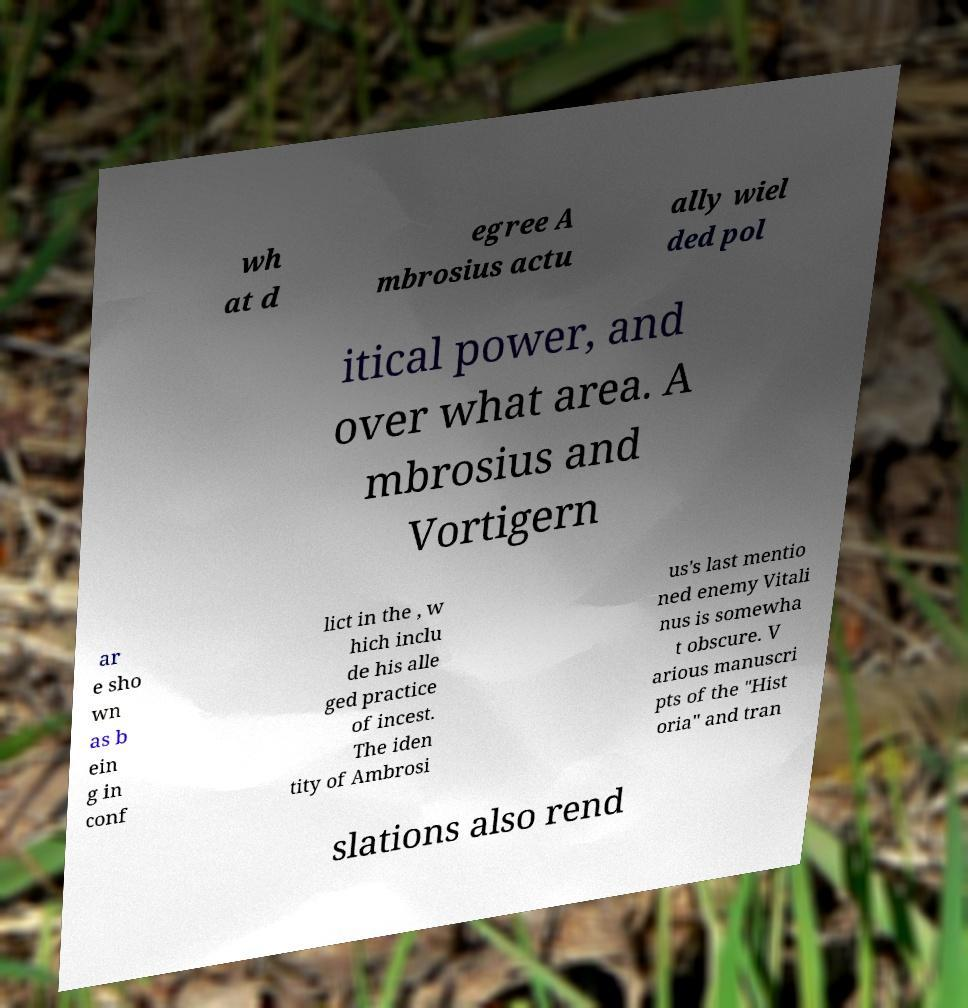Please read and relay the text visible in this image. What does it say? wh at d egree A mbrosius actu ally wiel ded pol itical power, and over what area. A mbrosius and Vortigern ar e sho wn as b ein g in conf lict in the , w hich inclu de his alle ged practice of incest. The iden tity of Ambrosi us's last mentio ned enemy Vitali nus is somewha t obscure. V arious manuscri pts of the "Hist oria" and tran slations also rend 